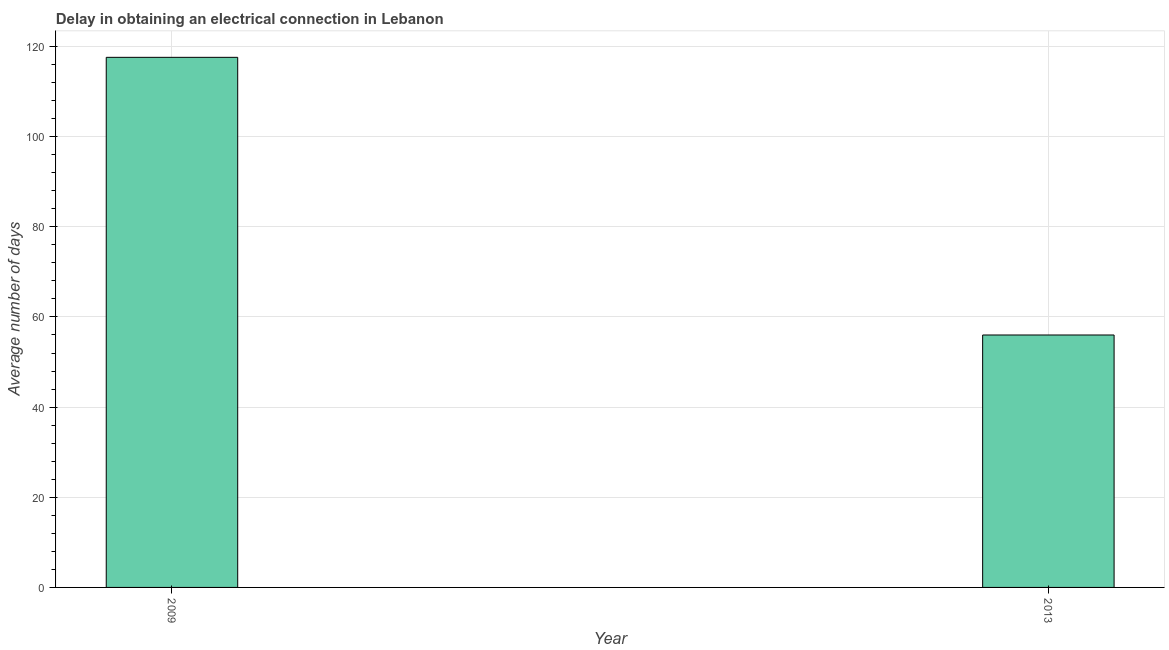Does the graph contain any zero values?
Provide a succinct answer. No. What is the title of the graph?
Provide a succinct answer. Delay in obtaining an electrical connection in Lebanon. What is the label or title of the Y-axis?
Make the answer very short. Average number of days. Across all years, what is the maximum dalay in electrical connection?
Provide a short and direct response. 117.6. In which year was the dalay in electrical connection maximum?
Give a very brief answer. 2009. In which year was the dalay in electrical connection minimum?
Keep it short and to the point. 2013. What is the sum of the dalay in electrical connection?
Your answer should be very brief. 173.6. What is the difference between the dalay in electrical connection in 2009 and 2013?
Your answer should be compact. 61.6. What is the average dalay in electrical connection per year?
Your answer should be compact. 86.8. What is the median dalay in electrical connection?
Offer a terse response. 86.8. In how many years, is the dalay in electrical connection greater than 48 days?
Offer a terse response. 2. What is the ratio of the dalay in electrical connection in 2009 to that in 2013?
Keep it short and to the point. 2.1. Is the dalay in electrical connection in 2009 less than that in 2013?
Provide a succinct answer. No. How many years are there in the graph?
Provide a succinct answer. 2. Are the values on the major ticks of Y-axis written in scientific E-notation?
Make the answer very short. No. What is the Average number of days in 2009?
Offer a very short reply. 117.6. What is the Average number of days in 2013?
Offer a very short reply. 56. What is the difference between the Average number of days in 2009 and 2013?
Make the answer very short. 61.6. What is the ratio of the Average number of days in 2009 to that in 2013?
Offer a terse response. 2.1. 